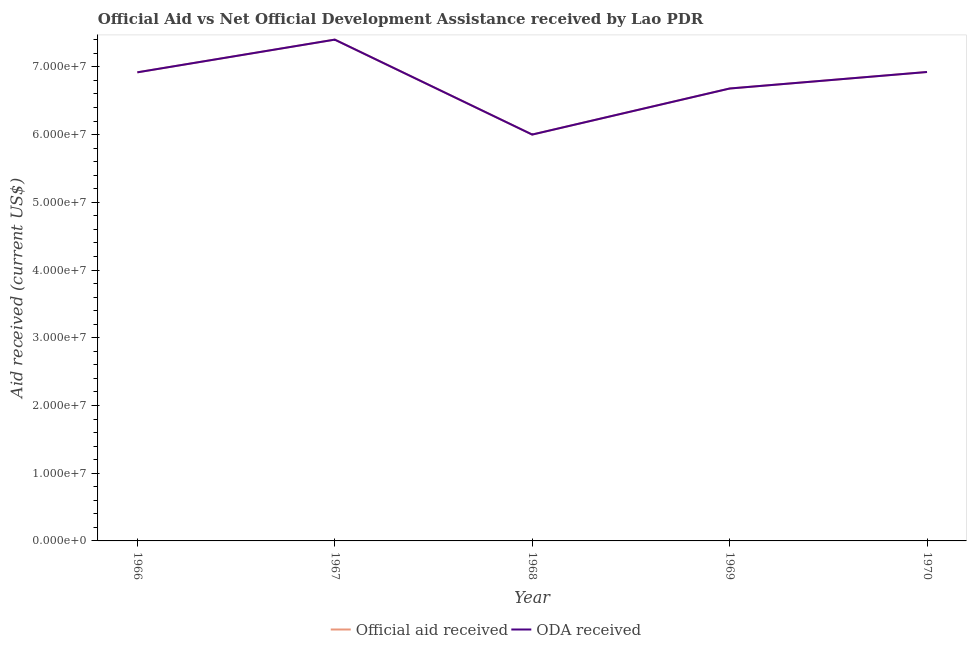Is the number of lines equal to the number of legend labels?
Provide a succinct answer. Yes. What is the official aid received in 1969?
Make the answer very short. 6.68e+07. Across all years, what is the maximum oda received?
Your answer should be compact. 7.40e+07. Across all years, what is the minimum official aid received?
Your answer should be compact. 6.00e+07. In which year was the oda received maximum?
Ensure brevity in your answer.  1967. In which year was the oda received minimum?
Your answer should be compact. 1968. What is the total official aid received in the graph?
Offer a terse response. 3.39e+08. What is the difference between the official aid received in 1966 and that in 1969?
Make the answer very short. 2.39e+06. What is the difference between the oda received in 1966 and the official aid received in 1969?
Your response must be concise. 2.39e+06. What is the average oda received per year?
Ensure brevity in your answer.  6.78e+07. In how many years, is the oda received greater than 2000000 US$?
Provide a short and direct response. 5. What is the ratio of the oda received in 1969 to that in 1970?
Ensure brevity in your answer.  0.96. Is the difference between the official aid received in 1968 and 1969 greater than the difference between the oda received in 1968 and 1969?
Offer a very short reply. No. What is the difference between the highest and the second highest official aid received?
Give a very brief answer. 4.78e+06. What is the difference between the highest and the lowest oda received?
Your answer should be compact. 1.40e+07. Is the oda received strictly less than the official aid received over the years?
Offer a terse response. No. How many lines are there?
Your response must be concise. 2. Are the values on the major ticks of Y-axis written in scientific E-notation?
Give a very brief answer. Yes. How many legend labels are there?
Ensure brevity in your answer.  2. How are the legend labels stacked?
Offer a terse response. Horizontal. What is the title of the graph?
Your answer should be very brief. Official Aid vs Net Official Development Assistance received by Lao PDR . What is the label or title of the X-axis?
Offer a terse response. Year. What is the label or title of the Y-axis?
Ensure brevity in your answer.  Aid received (current US$). What is the Aid received (current US$) in Official aid received in 1966?
Give a very brief answer. 6.92e+07. What is the Aid received (current US$) of ODA received in 1966?
Your answer should be compact. 6.92e+07. What is the Aid received (current US$) in Official aid received in 1967?
Offer a terse response. 7.40e+07. What is the Aid received (current US$) of ODA received in 1967?
Your response must be concise. 7.40e+07. What is the Aid received (current US$) in Official aid received in 1968?
Make the answer very short. 6.00e+07. What is the Aid received (current US$) of ODA received in 1968?
Offer a terse response. 6.00e+07. What is the Aid received (current US$) of Official aid received in 1969?
Offer a very short reply. 6.68e+07. What is the Aid received (current US$) in ODA received in 1969?
Offer a very short reply. 6.68e+07. What is the Aid received (current US$) in Official aid received in 1970?
Provide a succinct answer. 6.92e+07. What is the Aid received (current US$) of ODA received in 1970?
Give a very brief answer. 6.92e+07. Across all years, what is the maximum Aid received (current US$) of Official aid received?
Your response must be concise. 7.40e+07. Across all years, what is the maximum Aid received (current US$) in ODA received?
Offer a terse response. 7.40e+07. Across all years, what is the minimum Aid received (current US$) in Official aid received?
Ensure brevity in your answer.  6.00e+07. Across all years, what is the minimum Aid received (current US$) of ODA received?
Provide a succinct answer. 6.00e+07. What is the total Aid received (current US$) in Official aid received in the graph?
Keep it short and to the point. 3.39e+08. What is the total Aid received (current US$) in ODA received in the graph?
Offer a very short reply. 3.39e+08. What is the difference between the Aid received (current US$) in Official aid received in 1966 and that in 1967?
Your answer should be very brief. -4.83e+06. What is the difference between the Aid received (current US$) of ODA received in 1966 and that in 1967?
Your answer should be very brief. -4.83e+06. What is the difference between the Aid received (current US$) in Official aid received in 1966 and that in 1968?
Offer a very short reply. 9.19e+06. What is the difference between the Aid received (current US$) in ODA received in 1966 and that in 1968?
Offer a very short reply. 9.19e+06. What is the difference between the Aid received (current US$) of Official aid received in 1966 and that in 1969?
Your answer should be very brief. 2.39e+06. What is the difference between the Aid received (current US$) in ODA received in 1966 and that in 1969?
Ensure brevity in your answer.  2.39e+06. What is the difference between the Aid received (current US$) of Official aid received in 1966 and that in 1970?
Offer a terse response. -5.00e+04. What is the difference between the Aid received (current US$) of Official aid received in 1967 and that in 1968?
Offer a very short reply. 1.40e+07. What is the difference between the Aid received (current US$) in ODA received in 1967 and that in 1968?
Offer a terse response. 1.40e+07. What is the difference between the Aid received (current US$) in Official aid received in 1967 and that in 1969?
Keep it short and to the point. 7.22e+06. What is the difference between the Aid received (current US$) in ODA received in 1967 and that in 1969?
Offer a very short reply. 7.22e+06. What is the difference between the Aid received (current US$) of Official aid received in 1967 and that in 1970?
Provide a succinct answer. 4.78e+06. What is the difference between the Aid received (current US$) of ODA received in 1967 and that in 1970?
Give a very brief answer. 4.78e+06. What is the difference between the Aid received (current US$) of Official aid received in 1968 and that in 1969?
Your answer should be very brief. -6.80e+06. What is the difference between the Aid received (current US$) in ODA received in 1968 and that in 1969?
Provide a short and direct response. -6.80e+06. What is the difference between the Aid received (current US$) of Official aid received in 1968 and that in 1970?
Keep it short and to the point. -9.24e+06. What is the difference between the Aid received (current US$) of ODA received in 1968 and that in 1970?
Your answer should be compact. -9.24e+06. What is the difference between the Aid received (current US$) in Official aid received in 1969 and that in 1970?
Keep it short and to the point. -2.44e+06. What is the difference between the Aid received (current US$) in ODA received in 1969 and that in 1970?
Give a very brief answer. -2.44e+06. What is the difference between the Aid received (current US$) in Official aid received in 1966 and the Aid received (current US$) in ODA received in 1967?
Offer a terse response. -4.83e+06. What is the difference between the Aid received (current US$) of Official aid received in 1966 and the Aid received (current US$) of ODA received in 1968?
Give a very brief answer. 9.19e+06. What is the difference between the Aid received (current US$) in Official aid received in 1966 and the Aid received (current US$) in ODA received in 1969?
Give a very brief answer. 2.39e+06. What is the difference between the Aid received (current US$) of Official aid received in 1967 and the Aid received (current US$) of ODA received in 1968?
Offer a terse response. 1.40e+07. What is the difference between the Aid received (current US$) in Official aid received in 1967 and the Aid received (current US$) in ODA received in 1969?
Provide a succinct answer. 7.22e+06. What is the difference between the Aid received (current US$) in Official aid received in 1967 and the Aid received (current US$) in ODA received in 1970?
Provide a short and direct response. 4.78e+06. What is the difference between the Aid received (current US$) of Official aid received in 1968 and the Aid received (current US$) of ODA received in 1969?
Give a very brief answer. -6.80e+06. What is the difference between the Aid received (current US$) of Official aid received in 1968 and the Aid received (current US$) of ODA received in 1970?
Your answer should be very brief. -9.24e+06. What is the difference between the Aid received (current US$) in Official aid received in 1969 and the Aid received (current US$) in ODA received in 1970?
Offer a very short reply. -2.44e+06. What is the average Aid received (current US$) in Official aid received per year?
Provide a succinct answer. 6.78e+07. What is the average Aid received (current US$) in ODA received per year?
Keep it short and to the point. 6.78e+07. In the year 1966, what is the difference between the Aid received (current US$) of Official aid received and Aid received (current US$) of ODA received?
Your response must be concise. 0. In the year 1967, what is the difference between the Aid received (current US$) of Official aid received and Aid received (current US$) of ODA received?
Keep it short and to the point. 0. In the year 1969, what is the difference between the Aid received (current US$) of Official aid received and Aid received (current US$) of ODA received?
Give a very brief answer. 0. What is the ratio of the Aid received (current US$) in Official aid received in 1966 to that in 1967?
Your response must be concise. 0.93. What is the ratio of the Aid received (current US$) in ODA received in 1966 to that in 1967?
Offer a terse response. 0.93. What is the ratio of the Aid received (current US$) of Official aid received in 1966 to that in 1968?
Your answer should be compact. 1.15. What is the ratio of the Aid received (current US$) of ODA received in 1966 to that in 1968?
Provide a succinct answer. 1.15. What is the ratio of the Aid received (current US$) in Official aid received in 1966 to that in 1969?
Offer a terse response. 1.04. What is the ratio of the Aid received (current US$) of ODA received in 1966 to that in 1969?
Give a very brief answer. 1.04. What is the ratio of the Aid received (current US$) in ODA received in 1966 to that in 1970?
Provide a succinct answer. 1. What is the ratio of the Aid received (current US$) in Official aid received in 1967 to that in 1968?
Offer a very short reply. 1.23. What is the ratio of the Aid received (current US$) of ODA received in 1967 to that in 1968?
Your response must be concise. 1.23. What is the ratio of the Aid received (current US$) of Official aid received in 1967 to that in 1969?
Give a very brief answer. 1.11. What is the ratio of the Aid received (current US$) of ODA received in 1967 to that in 1969?
Your answer should be very brief. 1.11. What is the ratio of the Aid received (current US$) of Official aid received in 1967 to that in 1970?
Give a very brief answer. 1.07. What is the ratio of the Aid received (current US$) of ODA received in 1967 to that in 1970?
Your response must be concise. 1.07. What is the ratio of the Aid received (current US$) in Official aid received in 1968 to that in 1969?
Your answer should be very brief. 0.9. What is the ratio of the Aid received (current US$) in ODA received in 1968 to that in 1969?
Provide a succinct answer. 0.9. What is the ratio of the Aid received (current US$) of Official aid received in 1968 to that in 1970?
Your response must be concise. 0.87. What is the ratio of the Aid received (current US$) in ODA received in 1968 to that in 1970?
Your answer should be very brief. 0.87. What is the ratio of the Aid received (current US$) in Official aid received in 1969 to that in 1970?
Provide a short and direct response. 0.96. What is the ratio of the Aid received (current US$) in ODA received in 1969 to that in 1970?
Your answer should be very brief. 0.96. What is the difference between the highest and the second highest Aid received (current US$) of Official aid received?
Offer a terse response. 4.78e+06. What is the difference between the highest and the second highest Aid received (current US$) of ODA received?
Provide a succinct answer. 4.78e+06. What is the difference between the highest and the lowest Aid received (current US$) of Official aid received?
Provide a succinct answer. 1.40e+07. What is the difference between the highest and the lowest Aid received (current US$) of ODA received?
Offer a very short reply. 1.40e+07. 